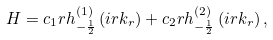Convert formula to latex. <formula><loc_0><loc_0><loc_500><loc_500>H = c _ { 1 } r h ^ { ( 1 ) } _ { - \frac { 1 } { 2 } } \left ( i r k _ { r } \right ) + c _ { 2 } r h ^ { ( 2 ) } _ { - \frac { 1 } { 2 } } \left ( i r k _ { r } \right ) ,</formula> 